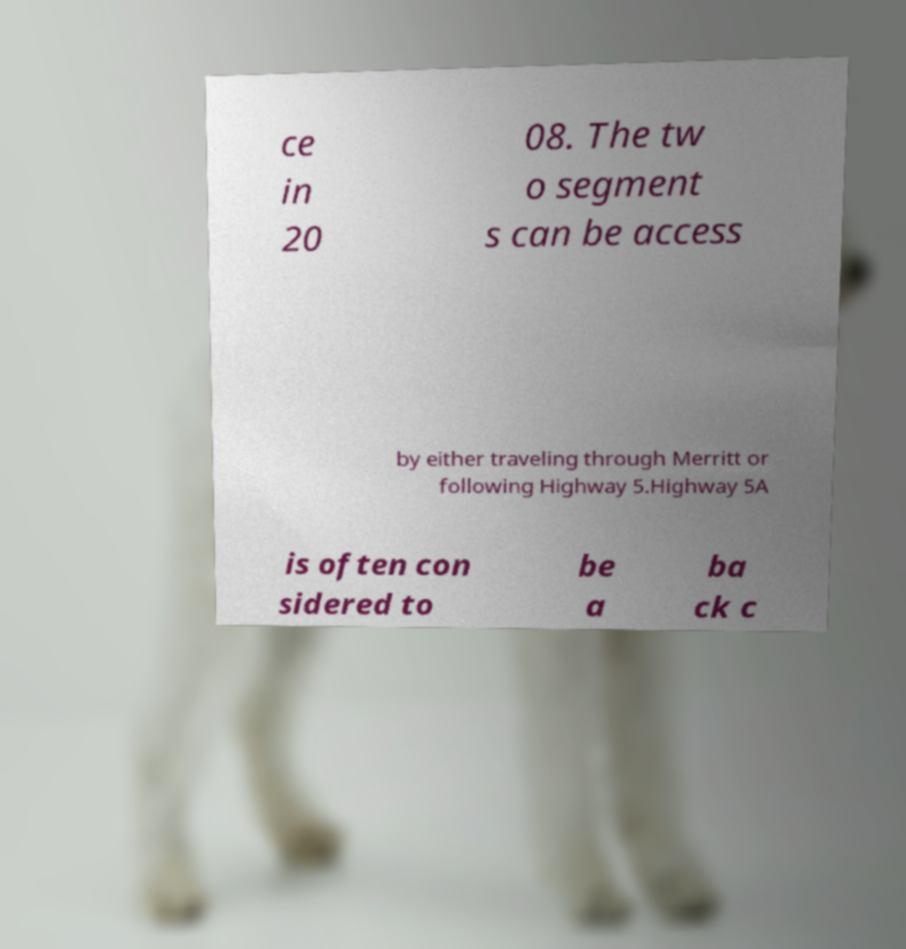Could you extract and type out the text from this image? ce in 20 08. The tw o segment s can be access by either traveling through Merritt or following Highway 5.Highway 5A is often con sidered to be a ba ck c 